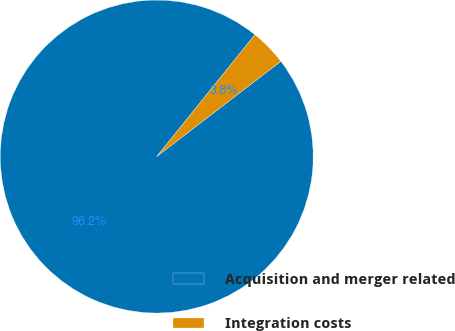Convert chart. <chart><loc_0><loc_0><loc_500><loc_500><pie_chart><fcel>Acquisition and merger related<fcel>Integration costs<nl><fcel>96.21%<fcel>3.79%<nl></chart> 